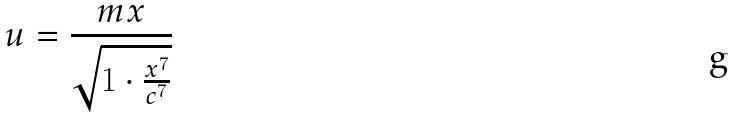<formula> <loc_0><loc_0><loc_500><loc_500>u = \frac { m x } { \sqrt { 1 \cdot \frac { x ^ { 7 } } { c ^ { 7 } } } }</formula> 